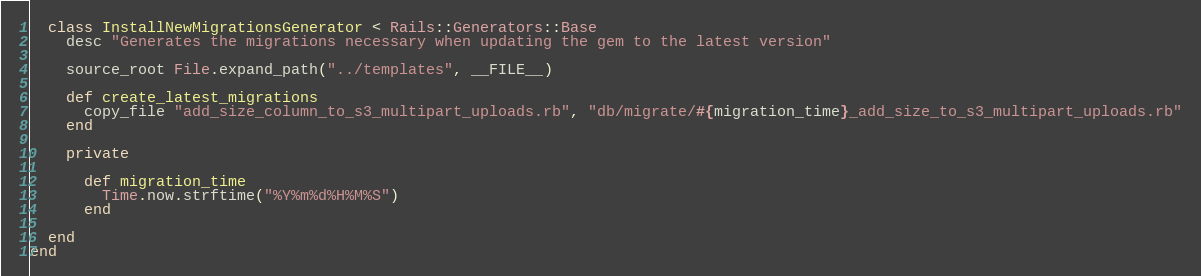<code> <loc_0><loc_0><loc_500><loc_500><_Ruby_>  class InstallNewMigrationsGenerator < Rails::Generators::Base
    desc "Generates the migrations necessary when updating the gem to the latest version"

    source_root File.expand_path("../templates", __FILE__)

    def create_latest_migrations
      copy_file "add_size_column_to_s3_multipart_uploads.rb", "db/migrate/#{migration_time}_add_size_to_s3_multipart_uploads.rb"
    end

    private

      def migration_time
        Time.now.strftime("%Y%m%d%H%M%S")
      end

  end
end
</code> 